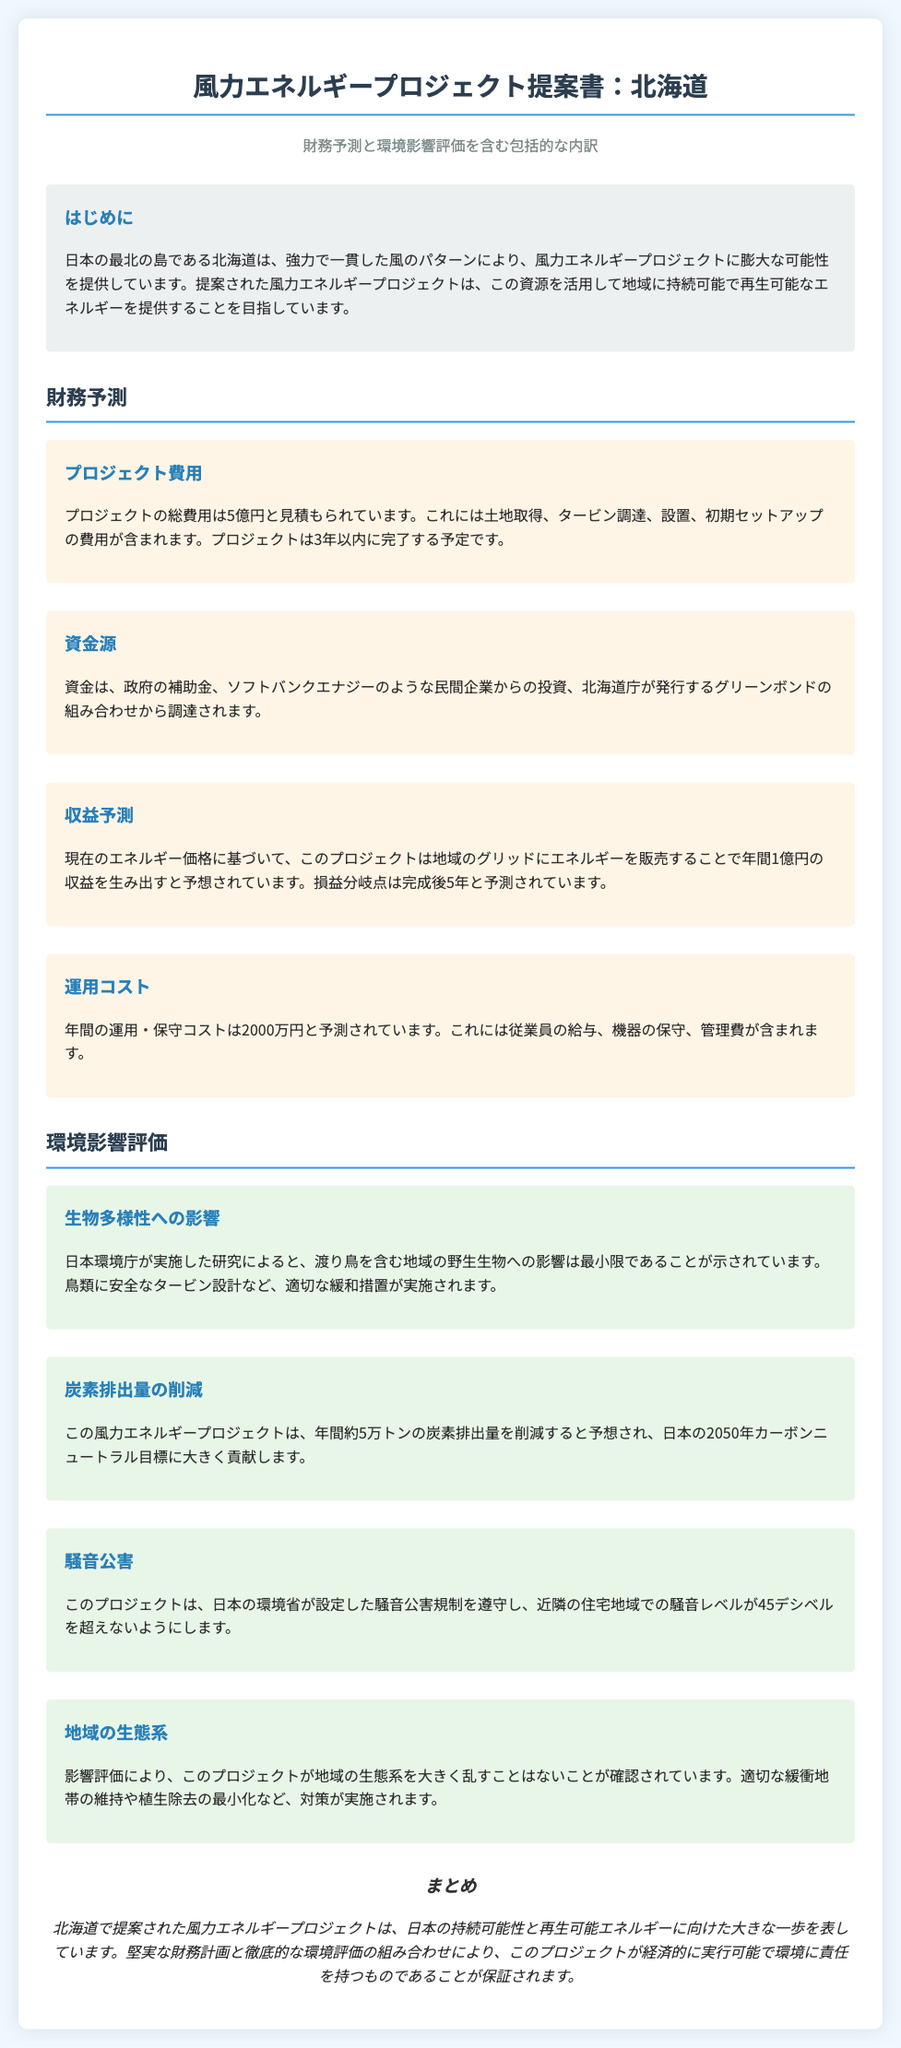What is the total cost of the project? The total cost of the project is mentioned in the financial projections section.
Answer: 5億円 What is the expected annual revenue from the project? The expected annual revenue is listed in the financial projections section based on current energy prices.
Answer: 1億円 In how many years is the project expected to be completed? The duration for project completion is specified in the project cost section.
Answer: 3年 What is the projected reduction in carbon emissions per year? The reduction in carbon emissions is provided in the environmental impact assessment section.
Answer: 約5万トン Which type of birds are specifically mentioned in the environmental impact section? The environmental impact section refers to specific wildlife affected.
Answer: 渡り鳥 What is the estimated annual operation and maintenance cost? The operational cost is detailed in the financial projections section.
Answer: 2000万円 What is the compliance noise level limit set by the Ministry of the Environment? Noise restrictions are outlined in the environmental impact assessments.
Answer: 45デシベル What combination of funding sources is mentioned for this project? The sources of funding are outlined in the financial projections section of the document.
Answer: 政府の補助金、民間企業からの投資、グリーンボンド What is the main focus of the wind energy project in Hokkaido? The introduction briefly discusses the purpose of the project.
Answer: 持続可能で再生可能なエネルギーを提供すること 